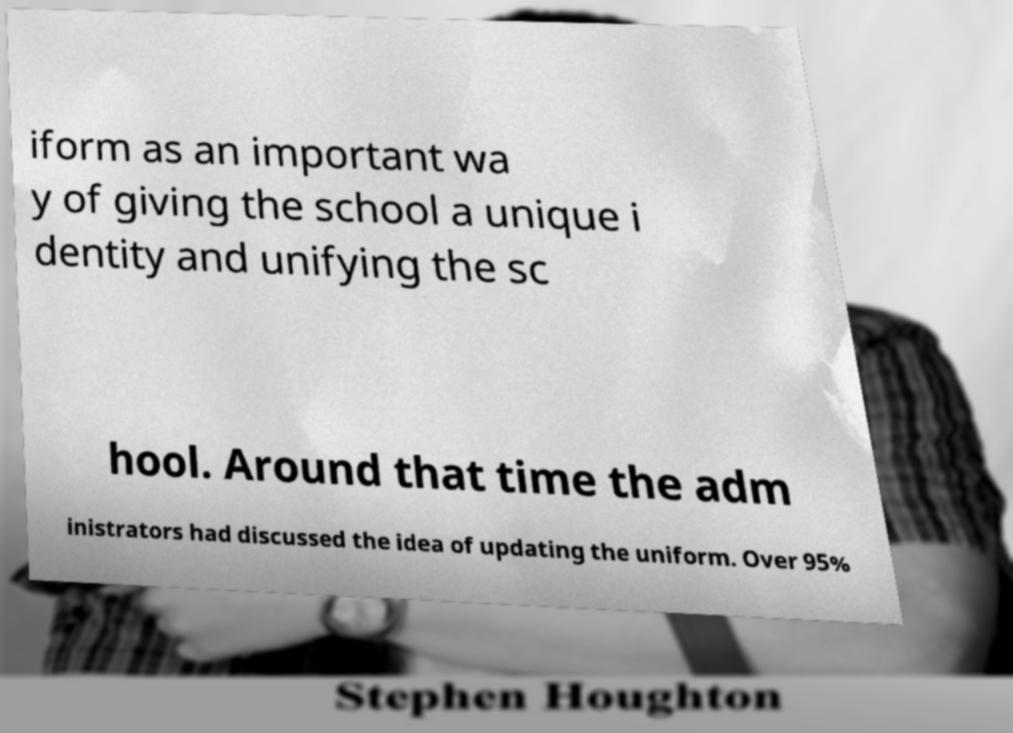There's text embedded in this image that I need extracted. Can you transcribe it verbatim? iform as an important wa y of giving the school a unique i dentity and unifying the sc hool. Around that time the adm inistrators had discussed the idea of updating the uniform. Over 95% 